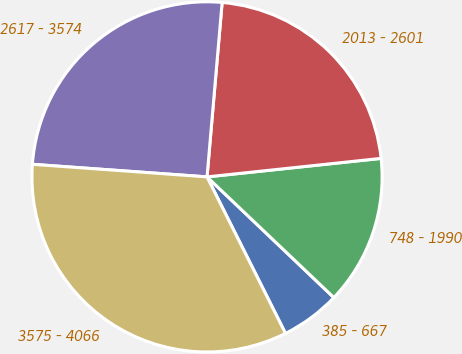Convert chart to OTSL. <chart><loc_0><loc_0><loc_500><loc_500><pie_chart><fcel>385 - 667<fcel>748 - 1990<fcel>2013 - 2601<fcel>2617 - 3574<fcel>3575 - 4066<nl><fcel>5.5%<fcel>13.79%<fcel>21.94%<fcel>25.23%<fcel>33.54%<nl></chart> 